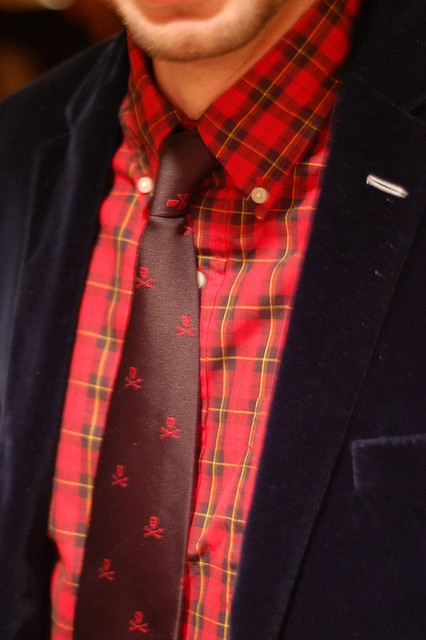Describe the objects in this image and their specific colors. I can see people in black, maroon, salmon, and brown tones and tie in maroon and brown tones in this image. 